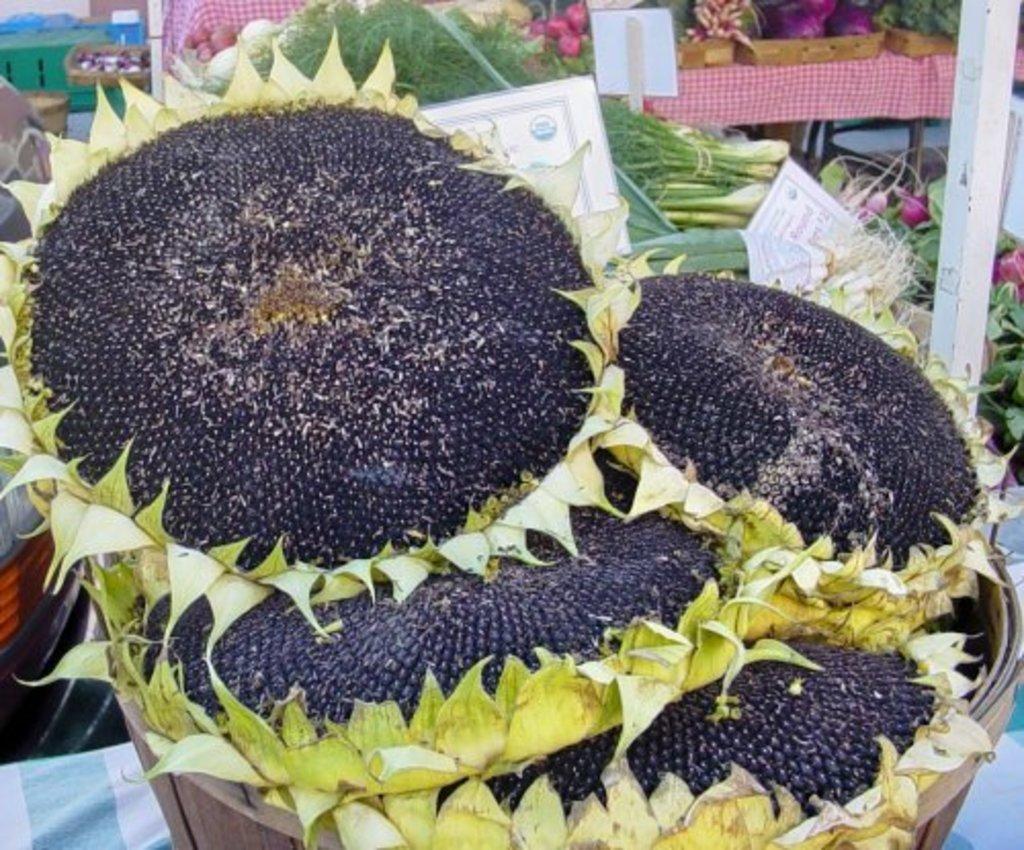Describe this image in one or two sentences. In this image we can see sunflowers planted in the basket. In the background we can see vegetables and leafy vegetables placed in the baskets along with the information boards. 